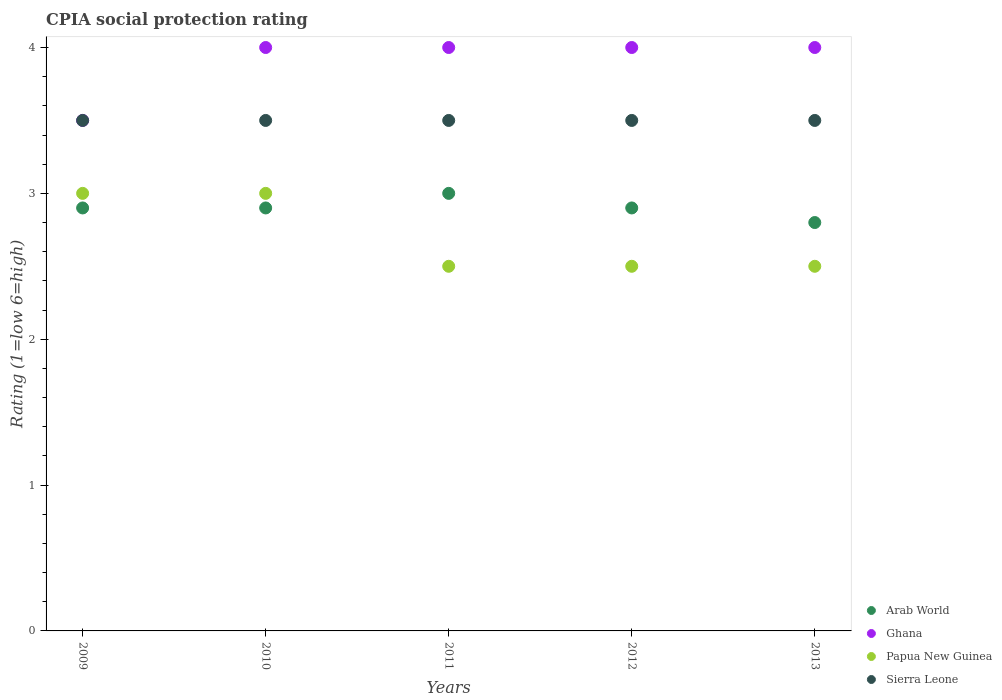How many different coloured dotlines are there?
Make the answer very short. 4. Is the number of dotlines equal to the number of legend labels?
Give a very brief answer. Yes. Across all years, what is the maximum CPIA rating in Sierra Leone?
Offer a very short reply. 3.5. In which year was the CPIA rating in Sierra Leone maximum?
Keep it short and to the point. 2009. In which year was the CPIA rating in Papua New Guinea minimum?
Your response must be concise. 2011. What is the total CPIA rating in Sierra Leone in the graph?
Provide a short and direct response. 17.5. What is the difference between the CPIA rating in Papua New Guinea in 2009 and that in 2012?
Offer a very short reply. 0.5. What is the difference between the CPIA rating in Arab World in 2013 and the CPIA rating in Ghana in 2010?
Keep it short and to the point. -1.2. In the year 2009, what is the difference between the CPIA rating in Arab World and CPIA rating in Ghana?
Give a very brief answer. -0.6. In how many years, is the CPIA rating in Sierra Leone greater than 2.6?
Make the answer very short. 5. Is the CPIA rating in Sierra Leone in 2010 less than that in 2012?
Your answer should be very brief. No. What is the difference between the highest and the second highest CPIA rating in Papua New Guinea?
Make the answer very short. 0. What is the difference between the highest and the lowest CPIA rating in Ghana?
Your answer should be very brief. 0.5. In how many years, is the CPIA rating in Papua New Guinea greater than the average CPIA rating in Papua New Guinea taken over all years?
Provide a succinct answer. 2. Is the sum of the CPIA rating in Sierra Leone in 2011 and 2012 greater than the maximum CPIA rating in Ghana across all years?
Keep it short and to the point. Yes. Is it the case that in every year, the sum of the CPIA rating in Papua New Guinea and CPIA rating in Ghana  is greater than the CPIA rating in Sierra Leone?
Your response must be concise. Yes. Is the CPIA rating in Arab World strictly greater than the CPIA rating in Ghana over the years?
Keep it short and to the point. No. What is the difference between two consecutive major ticks on the Y-axis?
Make the answer very short. 1. Does the graph contain any zero values?
Give a very brief answer. No. Does the graph contain grids?
Make the answer very short. No. Where does the legend appear in the graph?
Provide a succinct answer. Bottom right. How many legend labels are there?
Make the answer very short. 4. How are the legend labels stacked?
Ensure brevity in your answer.  Vertical. What is the title of the graph?
Keep it short and to the point. CPIA social protection rating. What is the label or title of the X-axis?
Provide a short and direct response. Years. What is the Rating (1=low 6=high) in Ghana in 2009?
Your response must be concise. 3.5. What is the Rating (1=low 6=high) of Papua New Guinea in 2009?
Provide a short and direct response. 3. What is the Rating (1=low 6=high) of Sierra Leone in 2010?
Offer a very short reply. 3.5. What is the Rating (1=low 6=high) in Arab World in 2011?
Provide a succinct answer. 3. What is the Rating (1=low 6=high) in Ghana in 2011?
Offer a very short reply. 4. What is the Rating (1=low 6=high) in Papua New Guinea in 2011?
Your answer should be compact. 2.5. What is the Rating (1=low 6=high) in Sierra Leone in 2011?
Make the answer very short. 3.5. What is the Rating (1=low 6=high) of Sierra Leone in 2012?
Offer a terse response. 3.5. What is the Rating (1=low 6=high) of Arab World in 2013?
Your response must be concise. 2.8. What is the Rating (1=low 6=high) in Ghana in 2013?
Your answer should be compact. 4. Across all years, what is the maximum Rating (1=low 6=high) in Arab World?
Offer a very short reply. 3. Across all years, what is the maximum Rating (1=low 6=high) of Papua New Guinea?
Your answer should be compact. 3. Across all years, what is the minimum Rating (1=low 6=high) in Ghana?
Keep it short and to the point. 3.5. Across all years, what is the minimum Rating (1=low 6=high) of Sierra Leone?
Ensure brevity in your answer.  3.5. What is the total Rating (1=low 6=high) in Ghana in the graph?
Offer a very short reply. 19.5. What is the difference between the Rating (1=low 6=high) in Arab World in 2009 and that in 2010?
Offer a very short reply. 0. What is the difference between the Rating (1=low 6=high) of Sierra Leone in 2009 and that in 2010?
Provide a succinct answer. 0. What is the difference between the Rating (1=low 6=high) of Sierra Leone in 2009 and that in 2011?
Offer a very short reply. 0. What is the difference between the Rating (1=low 6=high) of Arab World in 2009 and that in 2012?
Your answer should be compact. 0. What is the difference between the Rating (1=low 6=high) in Ghana in 2009 and that in 2012?
Your response must be concise. -0.5. What is the difference between the Rating (1=low 6=high) of Papua New Guinea in 2009 and that in 2012?
Provide a short and direct response. 0.5. What is the difference between the Rating (1=low 6=high) of Ghana in 2009 and that in 2013?
Your answer should be compact. -0.5. What is the difference between the Rating (1=low 6=high) in Sierra Leone in 2009 and that in 2013?
Your answer should be very brief. 0. What is the difference between the Rating (1=low 6=high) of Papua New Guinea in 2010 and that in 2011?
Your answer should be compact. 0.5. What is the difference between the Rating (1=low 6=high) of Arab World in 2010 and that in 2012?
Ensure brevity in your answer.  0. What is the difference between the Rating (1=low 6=high) of Sierra Leone in 2010 and that in 2012?
Provide a succinct answer. 0. What is the difference between the Rating (1=low 6=high) of Arab World in 2010 and that in 2013?
Ensure brevity in your answer.  0.1. What is the difference between the Rating (1=low 6=high) of Ghana in 2010 and that in 2013?
Make the answer very short. 0. What is the difference between the Rating (1=low 6=high) of Papua New Guinea in 2010 and that in 2013?
Provide a succinct answer. 0.5. What is the difference between the Rating (1=low 6=high) in Sierra Leone in 2010 and that in 2013?
Your answer should be compact. 0. What is the difference between the Rating (1=low 6=high) of Ghana in 2011 and that in 2012?
Ensure brevity in your answer.  0. What is the difference between the Rating (1=low 6=high) of Ghana in 2011 and that in 2013?
Provide a succinct answer. 0. What is the difference between the Rating (1=low 6=high) in Arab World in 2012 and that in 2013?
Your answer should be very brief. 0.1. What is the difference between the Rating (1=low 6=high) in Ghana in 2012 and that in 2013?
Provide a short and direct response. 0. What is the difference between the Rating (1=low 6=high) in Papua New Guinea in 2012 and that in 2013?
Ensure brevity in your answer.  0. What is the difference between the Rating (1=low 6=high) in Sierra Leone in 2012 and that in 2013?
Ensure brevity in your answer.  0. What is the difference between the Rating (1=low 6=high) in Arab World in 2009 and the Rating (1=low 6=high) in Ghana in 2010?
Keep it short and to the point. -1.1. What is the difference between the Rating (1=low 6=high) in Papua New Guinea in 2009 and the Rating (1=low 6=high) in Sierra Leone in 2010?
Your answer should be very brief. -0.5. What is the difference between the Rating (1=low 6=high) in Arab World in 2009 and the Rating (1=low 6=high) in Ghana in 2011?
Ensure brevity in your answer.  -1.1. What is the difference between the Rating (1=low 6=high) in Arab World in 2009 and the Rating (1=low 6=high) in Papua New Guinea in 2011?
Your answer should be very brief. 0.4. What is the difference between the Rating (1=low 6=high) of Arab World in 2009 and the Rating (1=low 6=high) of Sierra Leone in 2011?
Your response must be concise. -0.6. What is the difference between the Rating (1=low 6=high) of Ghana in 2009 and the Rating (1=low 6=high) of Papua New Guinea in 2011?
Offer a very short reply. 1. What is the difference between the Rating (1=low 6=high) in Papua New Guinea in 2009 and the Rating (1=low 6=high) in Sierra Leone in 2011?
Your answer should be very brief. -0.5. What is the difference between the Rating (1=low 6=high) of Ghana in 2009 and the Rating (1=low 6=high) of Papua New Guinea in 2012?
Keep it short and to the point. 1. What is the difference between the Rating (1=low 6=high) of Ghana in 2009 and the Rating (1=low 6=high) of Sierra Leone in 2012?
Give a very brief answer. 0. What is the difference between the Rating (1=low 6=high) in Arab World in 2009 and the Rating (1=low 6=high) in Ghana in 2013?
Make the answer very short. -1.1. What is the difference between the Rating (1=low 6=high) in Papua New Guinea in 2009 and the Rating (1=low 6=high) in Sierra Leone in 2013?
Offer a very short reply. -0.5. What is the difference between the Rating (1=low 6=high) in Arab World in 2010 and the Rating (1=low 6=high) in Sierra Leone in 2011?
Offer a terse response. -0.6. What is the difference between the Rating (1=low 6=high) of Ghana in 2010 and the Rating (1=low 6=high) of Sierra Leone in 2011?
Offer a very short reply. 0.5. What is the difference between the Rating (1=low 6=high) of Arab World in 2010 and the Rating (1=low 6=high) of Ghana in 2012?
Ensure brevity in your answer.  -1.1. What is the difference between the Rating (1=low 6=high) in Ghana in 2010 and the Rating (1=low 6=high) in Papua New Guinea in 2012?
Your answer should be very brief. 1.5. What is the difference between the Rating (1=low 6=high) of Ghana in 2010 and the Rating (1=low 6=high) of Sierra Leone in 2013?
Provide a short and direct response. 0.5. What is the difference between the Rating (1=low 6=high) in Papua New Guinea in 2010 and the Rating (1=low 6=high) in Sierra Leone in 2013?
Offer a terse response. -0.5. What is the difference between the Rating (1=low 6=high) of Ghana in 2011 and the Rating (1=low 6=high) of Sierra Leone in 2012?
Your answer should be very brief. 0.5. What is the difference between the Rating (1=low 6=high) of Papua New Guinea in 2011 and the Rating (1=low 6=high) of Sierra Leone in 2012?
Your response must be concise. -1. What is the difference between the Rating (1=low 6=high) of Arab World in 2011 and the Rating (1=low 6=high) of Sierra Leone in 2013?
Give a very brief answer. -0.5. What is the difference between the Rating (1=low 6=high) of Ghana in 2011 and the Rating (1=low 6=high) of Papua New Guinea in 2013?
Your response must be concise. 1.5. What is the difference between the Rating (1=low 6=high) of Arab World in 2012 and the Rating (1=low 6=high) of Ghana in 2013?
Provide a short and direct response. -1.1. What is the difference between the Rating (1=low 6=high) in Papua New Guinea in 2012 and the Rating (1=low 6=high) in Sierra Leone in 2013?
Your answer should be compact. -1. What is the average Rating (1=low 6=high) of Arab World per year?
Give a very brief answer. 2.9. What is the average Rating (1=low 6=high) of Sierra Leone per year?
Ensure brevity in your answer.  3.5. In the year 2009, what is the difference between the Rating (1=low 6=high) of Arab World and Rating (1=low 6=high) of Ghana?
Your answer should be very brief. -0.6. In the year 2009, what is the difference between the Rating (1=low 6=high) in Ghana and Rating (1=low 6=high) in Papua New Guinea?
Ensure brevity in your answer.  0.5. In the year 2009, what is the difference between the Rating (1=low 6=high) of Ghana and Rating (1=low 6=high) of Sierra Leone?
Your answer should be compact. 0. In the year 2010, what is the difference between the Rating (1=low 6=high) of Arab World and Rating (1=low 6=high) of Papua New Guinea?
Provide a succinct answer. -0.1. In the year 2010, what is the difference between the Rating (1=low 6=high) in Arab World and Rating (1=low 6=high) in Sierra Leone?
Give a very brief answer. -0.6. In the year 2011, what is the difference between the Rating (1=low 6=high) of Arab World and Rating (1=low 6=high) of Ghana?
Ensure brevity in your answer.  -1. In the year 2011, what is the difference between the Rating (1=low 6=high) in Arab World and Rating (1=low 6=high) in Sierra Leone?
Your answer should be very brief. -0.5. In the year 2011, what is the difference between the Rating (1=low 6=high) of Papua New Guinea and Rating (1=low 6=high) of Sierra Leone?
Keep it short and to the point. -1. In the year 2012, what is the difference between the Rating (1=low 6=high) in Ghana and Rating (1=low 6=high) in Papua New Guinea?
Ensure brevity in your answer.  1.5. In the year 2012, what is the difference between the Rating (1=low 6=high) in Papua New Guinea and Rating (1=low 6=high) in Sierra Leone?
Offer a terse response. -1. In the year 2013, what is the difference between the Rating (1=low 6=high) in Arab World and Rating (1=low 6=high) in Papua New Guinea?
Offer a terse response. 0.3. In the year 2013, what is the difference between the Rating (1=low 6=high) of Ghana and Rating (1=low 6=high) of Papua New Guinea?
Ensure brevity in your answer.  1.5. In the year 2013, what is the difference between the Rating (1=low 6=high) of Ghana and Rating (1=low 6=high) of Sierra Leone?
Ensure brevity in your answer.  0.5. In the year 2013, what is the difference between the Rating (1=low 6=high) in Papua New Guinea and Rating (1=low 6=high) in Sierra Leone?
Offer a terse response. -1. What is the ratio of the Rating (1=low 6=high) in Arab World in 2009 to that in 2010?
Your answer should be compact. 1. What is the ratio of the Rating (1=low 6=high) of Papua New Guinea in 2009 to that in 2010?
Offer a very short reply. 1. What is the ratio of the Rating (1=low 6=high) in Arab World in 2009 to that in 2011?
Keep it short and to the point. 0.97. What is the ratio of the Rating (1=low 6=high) of Papua New Guinea in 2009 to that in 2011?
Keep it short and to the point. 1.2. What is the ratio of the Rating (1=low 6=high) in Sierra Leone in 2009 to that in 2012?
Provide a short and direct response. 1. What is the ratio of the Rating (1=low 6=high) of Arab World in 2009 to that in 2013?
Ensure brevity in your answer.  1.04. What is the ratio of the Rating (1=low 6=high) in Sierra Leone in 2009 to that in 2013?
Provide a short and direct response. 1. What is the ratio of the Rating (1=low 6=high) in Arab World in 2010 to that in 2011?
Give a very brief answer. 0.97. What is the ratio of the Rating (1=low 6=high) in Papua New Guinea in 2010 to that in 2011?
Ensure brevity in your answer.  1.2. What is the ratio of the Rating (1=low 6=high) of Ghana in 2010 to that in 2012?
Offer a terse response. 1. What is the ratio of the Rating (1=low 6=high) of Papua New Guinea in 2010 to that in 2012?
Offer a very short reply. 1.2. What is the ratio of the Rating (1=low 6=high) in Sierra Leone in 2010 to that in 2012?
Your answer should be compact. 1. What is the ratio of the Rating (1=low 6=high) of Arab World in 2010 to that in 2013?
Offer a terse response. 1.04. What is the ratio of the Rating (1=low 6=high) in Ghana in 2010 to that in 2013?
Provide a succinct answer. 1. What is the ratio of the Rating (1=low 6=high) of Papua New Guinea in 2010 to that in 2013?
Offer a very short reply. 1.2. What is the ratio of the Rating (1=low 6=high) in Sierra Leone in 2010 to that in 2013?
Keep it short and to the point. 1. What is the ratio of the Rating (1=low 6=high) in Arab World in 2011 to that in 2012?
Your response must be concise. 1.03. What is the ratio of the Rating (1=low 6=high) of Papua New Guinea in 2011 to that in 2012?
Provide a succinct answer. 1. What is the ratio of the Rating (1=low 6=high) in Arab World in 2011 to that in 2013?
Your response must be concise. 1.07. What is the ratio of the Rating (1=low 6=high) of Papua New Guinea in 2011 to that in 2013?
Ensure brevity in your answer.  1. What is the ratio of the Rating (1=low 6=high) in Sierra Leone in 2011 to that in 2013?
Offer a very short reply. 1. What is the ratio of the Rating (1=low 6=high) in Arab World in 2012 to that in 2013?
Provide a short and direct response. 1.04. What is the difference between the highest and the second highest Rating (1=low 6=high) of Arab World?
Offer a terse response. 0.1. What is the difference between the highest and the second highest Rating (1=low 6=high) of Ghana?
Your response must be concise. 0. What is the difference between the highest and the lowest Rating (1=low 6=high) of Ghana?
Keep it short and to the point. 0.5. What is the difference between the highest and the lowest Rating (1=low 6=high) of Sierra Leone?
Keep it short and to the point. 0. 